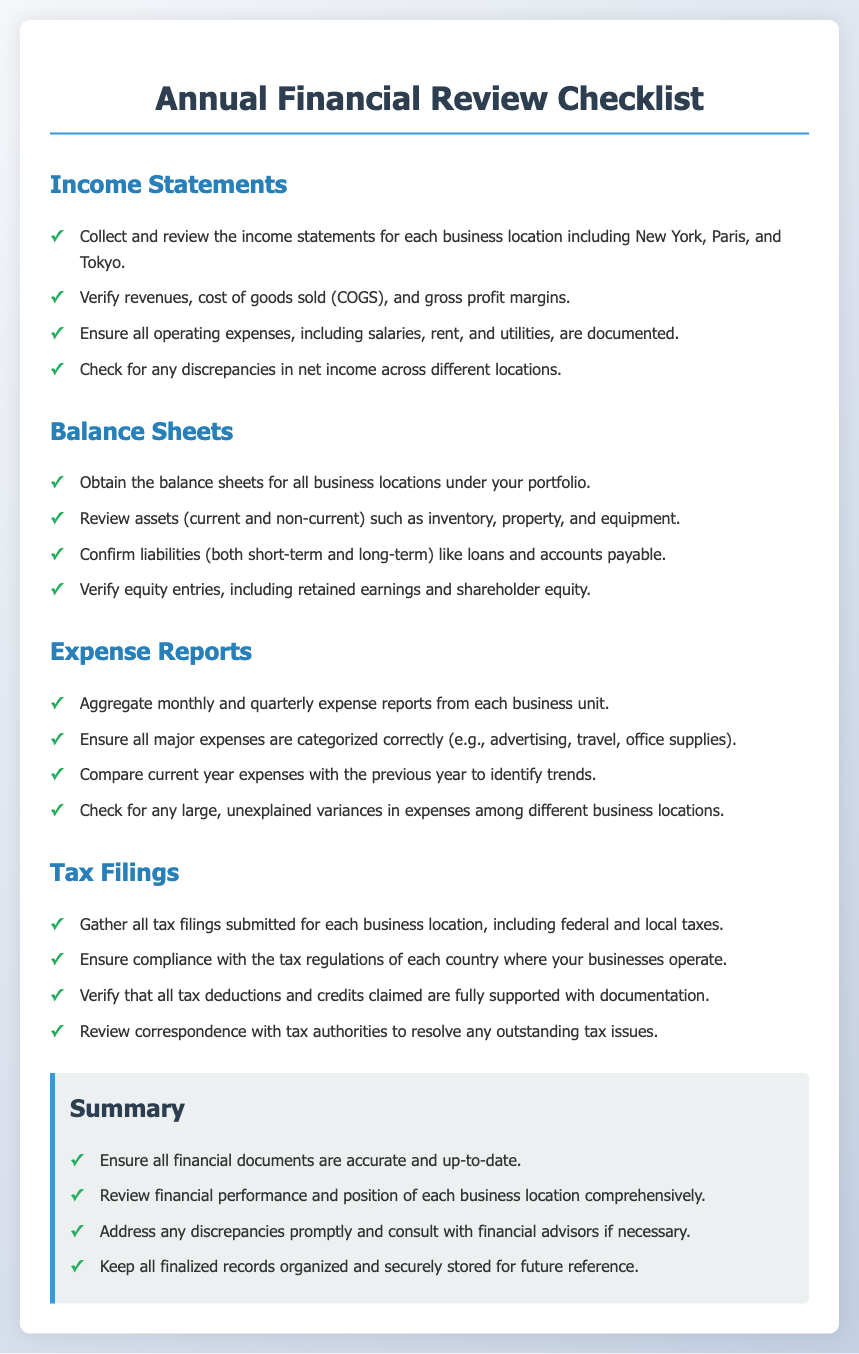what are the business locations mentioned in the checklist? The document lists specific business locations for financial review, which include New York, Paris, and Tokyo.
Answer: New York, Paris, Tokyo how many sections are in the checklist? The document has multiple sections detailing various financial aspects, which total four sections: Income Statements, Balance Sheets, Expense Reports, and Tax Filings.
Answer: four what should be verified in the balance sheets? The checklist specifies that liabilities must include both short-term and long-term obligations, such as loans and accounts payable.
Answer: liabilities what type of expenses should be categorized correctly? The checklist indicates several types of major expenses that need proper categorization, like advertising, travel, and office supplies.
Answer: advertising, travel, office supplies what is required to ensure compliance for tax filings? The checklist states a necessity to ensure compliance with tax regulations applicable to each country where the businesses operate.
Answer: compliance with tax regulations how often should expense reports be aggregated? The checklist suggests that expense reports should be aggregated monthly and quarterly from each business unit.
Answer: monthly and quarterly what action should be taken if discrepancies are found? The checklist recommends addressing any discrepancies promptly and if necessary, consulting with financial advisors.
Answer: consult with financial advisors what is included in the summary section? The summary section highlights key actions such as ensuring financial documents are accurate and reviewing financial performance comprehensively.
Answer: ensure all financial documents are accurate which financial document requires verification of tax deductions? According to the checklist, tax filings necessitate the verification of all claimed tax deductions and credits supported by documentation.
Answer: tax filings 